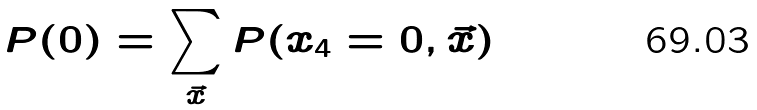<formula> <loc_0><loc_0><loc_500><loc_500>P ( 0 ) = \sum _ { \vec { x } } P ( x _ { 4 } = 0 , \vec { x } )</formula> 